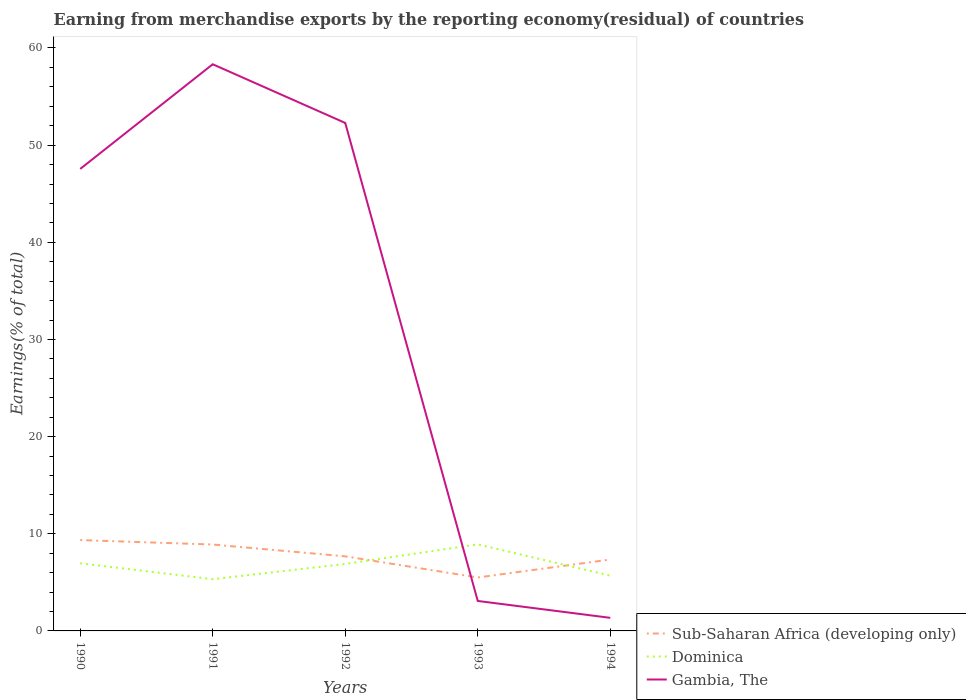Does the line corresponding to Dominica intersect with the line corresponding to Gambia, The?
Provide a succinct answer. Yes. Across all years, what is the maximum percentage of amount earned from merchandise exports in Sub-Saharan Africa (developing only)?
Offer a terse response. 5.5. What is the total percentage of amount earned from merchandise exports in Gambia, The in the graph?
Give a very brief answer. 49.2. What is the difference between the highest and the second highest percentage of amount earned from merchandise exports in Dominica?
Offer a very short reply. 3.58. Is the percentage of amount earned from merchandise exports in Gambia, The strictly greater than the percentage of amount earned from merchandise exports in Sub-Saharan Africa (developing only) over the years?
Your answer should be very brief. No. How many lines are there?
Your answer should be very brief. 3. How many years are there in the graph?
Your response must be concise. 5. What is the difference between two consecutive major ticks on the Y-axis?
Offer a very short reply. 10. Does the graph contain grids?
Your response must be concise. No. Where does the legend appear in the graph?
Offer a very short reply. Bottom right. How many legend labels are there?
Provide a succinct answer. 3. How are the legend labels stacked?
Make the answer very short. Vertical. What is the title of the graph?
Provide a short and direct response. Earning from merchandise exports by the reporting economy(residual) of countries. Does "Gambia, The" appear as one of the legend labels in the graph?
Your answer should be compact. Yes. What is the label or title of the X-axis?
Your response must be concise. Years. What is the label or title of the Y-axis?
Keep it short and to the point. Earnings(% of total). What is the Earnings(% of total) of Sub-Saharan Africa (developing only) in 1990?
Provide a short and direct response. 9.35. What is the Earnings(% of total) in Dominica in 1990?
Provide a succinct answer. 6.96. What is the Earnings(% of total) in Gambia, The in 1990?
Keep it short and to the point. 47.55. What is the Earnings(% of total) of Sub-Saharan Africa (developing only) in 1991?
Give a very brief answer. 8.89. What is the Earnings(% of total) in Dominica in 1991?
Provide a succinct answer. 5.32. What is the Earnings(% of total) of Gambia, The in 1991?
Keep it short and to the point. 58.33. What is the Earnings(% of total) of Sub-Saharan Africa (developing only) in 1992?
Provide a succinct answer. 7.68. What is the Earnings(% of total) of Dominica in 1992?
Ensure brevity in your answer.  6.89. What is the Earnings(% of total) of Gambia, The in 1992?
Your answer should be very brief. 52.28. What is the Earnings(% of total) of Sub-Saharan Africa (developing only) in 1993?
Your response must be concise. 5.5. What is the Earnings(% of total) of Dominica in 1993?
Keep it short and to the point. 8.91. What is the Earnings(% of total) in Gambia, The in 1993?
Provide a succinct answer. 3.08. What is the Earnings(% of total) of Sub-Saharan Africa (developing only) in 1994?
Your response must be concise. 7.35. What is the Earnings(% of total) of Dominica in 1994?
Keep it short and to the point. 5.69. What is the Earnings(% of total) in Gambia, The in 1994?
Provide a succinct answer. 1.35. Across all years, what is the maximum Earnings(% of total) in Sub-Saharan Africa (developing only)?
Provide a succinct answer. 9.35. Across all years, what is the maximum Earnings(% of total) of Dominica?
Provide a short and direct response. 8.91. Across all years, what is the maximum Earnings(% of total) of Gambia, The?
Ensure brevity in your answer.  58.33. Across all years, what is the minimum Earnings(% of total) in Sub-Saharan Africa (developing only)?
Your answer should be very brief. 5.5. Across all years, what is the minimum Earnings(% of total) in Dominica?
Make the answer very short. 5.32. Across all years, what is the minimum Earnings(% of total) of Gambia, The?
Provide a succinct answer. 1.35. What is the total Earnings(% of total) in Sub-Saharan Africa (developing only) in the graph?
Ensure brevity in your answer.  38.77. What is the total Earnings(% of total) in Dominica in the graph?
Keep it short and to the point. 33.78. What is the total Earnings(% of total) in Gambia, The in the graph?
Provide a short and direct response. 162.59. What is the difference between the Earnings(% of total) of Sub-Saharan Africa (developing only) in 1990 and that in 1991?
Make the answer very short. 0.46. What is the difference between the Earnings(% of total) in Dominica in 1990 and that in 1991?
Offer a terse response. 1.64. What is the difference between the Earnings(% of total) in Gambia, The in 1990 and that in 1991?
Give a very brief answer. -10.77. What is the difference between the Earnings(% of total) in Sub-Saharan Africa (developing only) in 1990 and that in 1992?
Ensure brevity in your answer.  1.67. What is the difference between the Earnings(% of total) in Dominica in 1990 and that in 1992?
Give a very brief answer. 0.07. What is the difference between the Earnings(% of total) in Gambia, The in 1990 and that in 1992?
Your response must be concise. -4.73. What is the difference between the Earnings(% of total) in Sub-Saharan Africa (developing only) in 1990 and that in 1993?
Make the answer very short. 3.85. What is the difference between the Earnings(% of total) in Dominica in 1990 and that in 1993?
Keep it short and to the point. -1.95. What is the difference between the Earnings(% of total) in Gambia, The in 1990 and that in 1993?
Ensure brevity in your answer.  44.47. What is the difference between the Earnings(% of total) in Sub-Saharan Africa (developing only) in 1990 and that in 1994?
Your answer should be compact. 2. What is the difference between the Earnings(% of total) in Dominica in 1990 and that in 1994?
Your response must be concise. 1.27. What is the difference between the Earnings(% of total) in Gambia, The in 1990 and that in 1994?
Provide a succinct answer. 46.21. What is the difference between the Earnings(% of total) in Sub-Saharan Africa (developing only) in 1991 and that in 1992?
Keep it short and to the point. 1.22. What is the difference between the Earnings(% of total) of Dominica in 1991 and that in 1992?
Offer a terse response. -1.57. What is the difference between the Earnings(% of total) of Gambia, The in 1991 and that in 1992?
Keep it short and to the point. 6.04. What is the difference between the Earnings(% of total) in Sub-Saharan Africa (developing only) in 1991 and that in 1993?
Keep it short and to the point. 3.39. What is the difference between the Earnings(% of total) in Dominica in 1991 and that in 1993?
Provide a succinct answer. -3.58. What is the difference between the Earnings(% of total) of Gambia, The in 1991 and that in 1993?
Make the answer very short. 55.24. What is the difference between the Earnings(% of total) of Sub-Saharan Africa (developing only) in 1991 and that in 1994?
Keep it short and to the point. 1.54. What is the difference between the Earnings(% of total) in Dominica in 1991 and that in 1994?
Offer a very short reply. -0.37. What is the difference between the Earnings(% of total) in Gambia, The in 1991 and that in 1994?
Ensure brevity in your answer.  56.98. What is the difference between the Earnings(% of total) in Sub-Saharan Africa (developing only) in 1992 and that in 1993?
Provide a short and direct response. 2.17. What is the difference between the Earnings(% of total) in Dominica in 1992 and that in 1993?
Your answer should be very brief. -2.01. What is the difference between the Earnings(% of total) in Gambia, The in 1992 and that in 1993?
Your answer should be compact. 49.2. What is the difference between the Earnings(% of total) of Sub-Saharan Africa (developing only) in 1992 and that in 1994?
Your answer should be very brief. 0.33. What is the difference between the Earnings(% of total) of Dominica in 1992 and that in 1994?
Make the answer very short. 1.2. What is the difference between the Earnings(% of total) of Gambia, The in 1992 and that in 1994?
Make the answer very short. 50.94. What is the difference between the Earnings(% of total) in Sub-Saharan Africa (developing only) in 1993 and that in 1994?
Your answer should be very brief. -1.85. What is the difference between the Earnings(% of total) of Dominica in 1993 and that in 1994?
Make the answer very short. 3.22. What is the difference between the Earnings(% of total) in Gambia, The in 1993 and that in 1994?
Offer a terse response. 1.74. What is the difference between the Earnings(% of total) in Sub-Saharan Africa (developing only) in 1990 and the Earnings(% of total) in Dominica in 1991?
Provide a succinct answer. 4.03. What is the difference between the Earnings(% of total) in Sub-Saharan Africa (developing only) in 1990 and the Earnings(% of total) in Gambia, The in 1991?
Keep it short and to the point. -48.97. What is the difference between the Earnings(% of total) of Dominica in 1990 and the Earnings(% of total) of Gambia, The in 1991?
Your response must be concise. -51.36. What is the difference between the Earnings(% of total) of Sub-Saharan Africa (developing only) in 1990 and the Earnings(% of total) of Dominica in 1992?
Provide a succinct answer. 2.46. What is the difference between the Earnings(% of total) of Sub-Saharan Africa (developing only) in 1990 and the Earnings(% of total) of Gambia, The in 1992?
Keep it short and to the point. -42.93. What is the difference between the Earnings(% of total) of Dominica in 1990 and the Earnings(% of total) of Gambia, The in 1992?
Offer a terse response. -45.32. What is the difference between the Earnings(% of total) in Sub-Saharan Africa (developing only) in 1990 and the Earnings(% of total) in Dominica in 1993?
Keep it short and to the point. 0.44. What is the difference between the Earnings(% of total) in Sub-Saharan Africa (developing only) in 1990 and the Earnings(% of total) in Gambia, The in 1993?
Make the answer very short. 6.27. What is the difference between the Earnings(% of total) in Dominica in 1990 and the Earnings(% of total) in Gambia, The in 1993?
Your answer should be compact. 3.88. What is the difference between the Earnings(% of total) of Sub-Saharan Africa (developing only) in 1990 and the Earnings(% of total) of Dominica in 1994?
Your answer should be very brief. 3.66. What is the difference between the Earnings(% of total) of Sub-Saharan Africa (developing only) in 1990 and the Earnings(% of total) of Gambia, The in 1994?
Your response must be concise. 8. What is the difference between the Earnings(% of total) in Dominica in 1990 and the Earnings(% of total) in Gambia, The in 1994?
Your answer should be very brief. 5.62. What is the difference between the Earnings(% of total) in Sub-Saharan Africa (developing only) in 1991 and the Earnings(% of total) in Dominica in 1992?
Your answer should be very brief. 2. What is the difference between the Earnings(% of total) in Sub-Saharan Africa (developing only) in 1991 and the Earnings(% of total) in Gambia, The in 1992?
Offer a very short reply. -43.39. What is the difference between the Earnings(% of total) in Dominica in 1991 and the Earnings(% of total) in Gambia, The in 1992?
Make the answer very short. -46.96. What is the difference between the Earnings(% of total) of Sub-Saharan Africa (developing only) in 1991 and the Earnings(% of total) of Dominica in 1993?
Provide a short and direct response. -0.02. What is the difference between the Earnings(% of total) of Sub-Saharan Africa (developing only) in 1991 and the Earnings(% of total) of Gambia, The in 1993?
Your response must be concise. 5.81. What is the difference between the Earnings(% of total) of Dominica in 1991 and the Earnings(% of total) of Gambia, The in 1993?
Your answer should be compact. 2.24. What is the difference between the Earnings(% of total) of Sub-Saharan Africa (developing only) in 1991 and the Earnings(% of total) of Dominica in 1994?
Provide a short and direct response. 3.2. What is the difference between the Earnings(% of total) in Sub-Saharan Africa (developing only) in 1991 and the Earnings(% of total) in Gambia, The in 1994?
Ensure brevity in your answer.  7.55. What is the difference between the Earnings(% of total) of Dominica in 1991 and the Earnings(% of total) of Gambia, The in 1994?
Provide a short and direct response. 3.98. What is the difference between the Earnings(% of total) in Sub-Saharan Africa (developing only) in 1992 and the Earnings(% of total) in Dominica in 1993?
Your answer should be compact. -1.23. What is the difference between the Earnings(% of total) of Sub-Saharan Africa (developing only) in 1992 and the Earnings(% of total) of Gambia, The in 1993?
Provide a succinct answer. 4.59. What is the difference between the Earnings(% of total) in Dominica in 1992 and the Earnings(% of total) in Gambia, The in 1993?
Provide a succinct answer. 3.81. What is the difference between the Earnings(% of total) of Sub-Saharan Africa (developing only) in 1992 and the Earnings(% of total) of Dominica in 1994?
Your response must be concise. 1.99. What is the difference between the Earnings(% of total) of Sub-Saharan Africa (developing only) in 1992 and the Earnings(% of total) of Gambia, The in 1994?
Ensure brevity in your answer.  6.33. What is the difference between the Earnings(% of total) of Dominica in 1992 and the Earnings(% of total) of Gambia, The in 1994?
Your answer should be compact. 5.55. What is the difference between the Earnings(% of total) in Sub-Saharan Africa (developing only) in 1993 and the Earnings(% of total) in Dominica in 1994?
Offer a terse response. -0.19. What is the difference between the Earnings(% of total) in Sub-Saharan Africa (developing only) in 1993 and the Earnings(% of total) in Gambia, The in 1994?
Your response must be concise. 4.15. What is the difference between the Earnings(% of total) of Dominica in 1993 and the Earnings(% of total) of Gambia, The in 1994?
Your response must be concise. 7.56. What is the average Earnings(% of total) in Sub-Saharan Africa (developing only) per year?
Keep it short and to the point. 7.75. What is the average Earnings(% of total) of Dominica per year?
Make the answer very short. 6.76. What is the average Earnings(% of total) in Gambia, The per year?
Your response must be concise. 32.52. In the year 1990, what is the difference between the Earnings(% of total) in Sub-Saharan Africa (developing only) and Earnings(% of total) in Dominica?
Provide a succinct answer. 2.39. In the year 1990, what is the difference between the Earnings(% of total) of Sub-Saharan Africa (developing only) and Earnings(% of total) of Gambia, The?
Offer a terse response. -38.2. In the year 1990, what is the difference between the Earnings(% of total) of Dominica and Earnings(% of total) of Gambia, The?
Your answer should be very brief. -40.59. In the year 1991, what is the difference between the Earnings(% of total) of Sub-Saharan Africa (developing only) and Earnings(% of total) of Dominica?
Provide a succinct answer. 3.57. In the year 1991, what is the difference between the Earnings(% of total) of Sub-Saharan Africa (developing only) and Earnings(% of total) of Gambia, The?
Provide a succinct answer. -49.43. In the year 1991, what is the difference between the Earnings(% of total) in Dominica and Earnings(% of total) in Gambia, The?
Your response must be concise. -53. In the year 1992, what is the difference between the Earnings(% of total) in Sub-Saharan Africa (developing only) and Earnings(% of total) in Dominica?
Keep it short and to the point. 0.78. In the year 1992, what is the difference between the Earnings(% of total) of Sub-Saharan Africa (developing only) and Earnings(% of total) of Gambia, The?
Make the answer very short. -44.61. In the year 1992, what is the difference between the Earnings(% of total) in Dominica and Earnings(% of total) in Gambia, The?
Your response must be concise. -45.39. In the year 1993, what is the difference between the Earnings(% of total) of Sub-Saharan Africa (developing only) and Earnings(% of total) of Dominica?
Provide a short and direct response. -3.41. In the year 1993, what is the difference between the Earnings(% of total) in Sub-Saharan Africa (developing only) and Earnings(% of total) in Gambia, The?
Keep it short and to the point. 2.42. In the year 1993, what is the difference between the Earnings(% of total) in Dominica and Earnings(% of total) in Gambia, The?
Provide a short and direct response. 5.83. In the year 1994, what is the difference between the Earnings(% of total) of Sub-Saharan Africa (developing only) and Earnings(% of total) of Dominica?
Offer a terse response. 1.66. In the year 1994, what is the difference between the Earnings(% of total) of Sub-Saharan Africa (developing only) and Earnings(% of total) of Gambia, The?
Ensure brevity in your answer.  6. In the year 1994, what is the difference between the Earnings(% of total) in Dominica and Earnings(% of total) in Gambia, The?
Ensure brevity in your answer.  4.34. What is the ratio of the Earnings(% of total) in Sub-Saharan Africa (developing only) in 1990 to that in 1991?
Keep it short and to the point. 1.05. What is the ratio of the Earnings(% of total) in Dominica in 1990 to that in 1991?
Your answer should be compact. 1.31. What is the ratio of the Earnings(% of total) of Gambia, The in 1990 to that in 1991?
Make the answer very short. 0.82. What is the ratio of the Earnings(% of total) in Sub-Saharan Africa (developing only) in 1990 to that in 1992?
Offer a very short reply. 1.22. What is the ratio of the Earnings(% of total) in Dominica in 1990 to that in 1992?
Provide a short and direct response. 1.01. What is the ratio of the Earnings(% of total) in Gambia, The in 1990 to that in 1992?
Provide a succinct answer. 0.91. What is the ratio of the Earnings(% of total) of Sub-Saharan Africa (developing only) in 1990 to that in 1993?
Ensure brevity in your answer.  1.7. What is the ratio of the Earnings(% of total) of Dominica in 1990 to that in 1993?
Provide a short and direct response. 0.78. What is the ratio of the Earnings(% of total) of Gambia, The in 1990 to that in 1993?
Ensure brevity in your answer.  15.42. What is the ratio of the Earnings(% of total) of Sub-Saharan Africa (developing only) in 1990 to that in 1994?
Make the answer very short. 1.27. What is the ratio of the Earnings(% of total) of Dominica in 1990 to that in 1994?
Make the answer very short. 1.22. What is the ratio of the Earnings(% of total) in Gambia, The in 1990 to that in 1994?
Your answer should be very brief. 35.31. What is the ratio of the Earnings(% of total) in Sub-Saharan Africa (developing only) in 1991 to that in 1992?
Keep it short and to the point. 1.16. What is the ratio of the Earnings(% of total) of Dominica in 1991 to that in 1992?
Your answer should be very brief. 0.77. What is the ratio of the Earnings(% of total) of Gambia, The in 1991 to that in 1992?
Offer a very short reply. 1.12. What is the ratio of the Earnings(% of total) of Sub-Saharan Africa (developing only) in 1991 to that in 1993?
Give a very brief answer. 1.62. What is the ratio of the Earnings(% of total) of Dominica in 1991 to that in 1993?
Make the answer very short. 0.6. What is the ratio of the Earnings(% of total) in Gambia, The in 1991 to that in 1993?
Provide a succinct answer. 18.92. What is the ratio of the Earnings(% of total) in Sub-Saharan Africa (developing only) in 1991 to that in 1994?
Ensure brevity in your answer.  1.21. What is the ratio of the Earnings(% of total) of Dominica in 1991 to that in 1994?
Your answer should be compact. 0.94. What is the ratio of the Earnings(% of total) of Gambia, The in 1991 to that in 1994?
Your answer should be very brief. 43.31. What is the ratio of the Earnings(% of total) of Sub-Saharan Africa (developing only) in 1992 to that in 1993?
Give a very brief answer. 1.4. What is the ratio of the Earnings(% of total) in Dominica in 1992 to that in 1993?
Make the answer very short. 0.77. What is the ratio of the Earnings(% of total) in Gambia, The in 1992 to that in 1993?
Keep it short and to the point. 16.96. What is the ratio of the Earnings(% of total) in Sub-Saharan Africa (developing only) in 1992 to that in 1994?
Make the answer very short. 1.04. What is the ratio of the Earnings(% of total) in Dominica in 1992 to that in 1994?
Your response must be concise. 1.21. What is the ratio of the Earnings(% of total) of Gambia, The in 1992 to that in 1994?
Give a very brief answer. 38.83. What is the ratio of the Earnings(% of total) in Sub-Saharan Africa (developing only) in 1993 to that in 1994?
Your response must be concise. 0.75. What is the ratio of the Earnings(% of total) of Dominica in 1993 to that in 1994?
Your response must be concise. 1.57. What is the ratio of the Earnings(% of total) in Gambia, The in 1993 to that in 1994?
Make the answer very short. 2.29. What is the difference between the highest and the second highest Earnings(% of total) in Sub-Saharan Africa (developing only)?
Provide a succinct answer. 0.46. What is the difference between the highest and the second highest Earnings(% of total) of Dominica?
Your answer should be compact. 1.95. What is the difference between the highest and the second highest Earnings(% of total) in Gambia, The?
Your response must be concise. 6.04. What is the difference between the highest and the lowest Earnings(% of total) in Sub-Saharan Africa (developing only)?
Your answer should be very brief. 3.85. What is the difference between the highest and the lowest Earnings(% of total) in Dominica?
Offer a very short reply. 3.58. What is the difference between the highest and the lowest Earnings(% of total) in Gambia, The?
Provide a short and direct response. 56.98. 